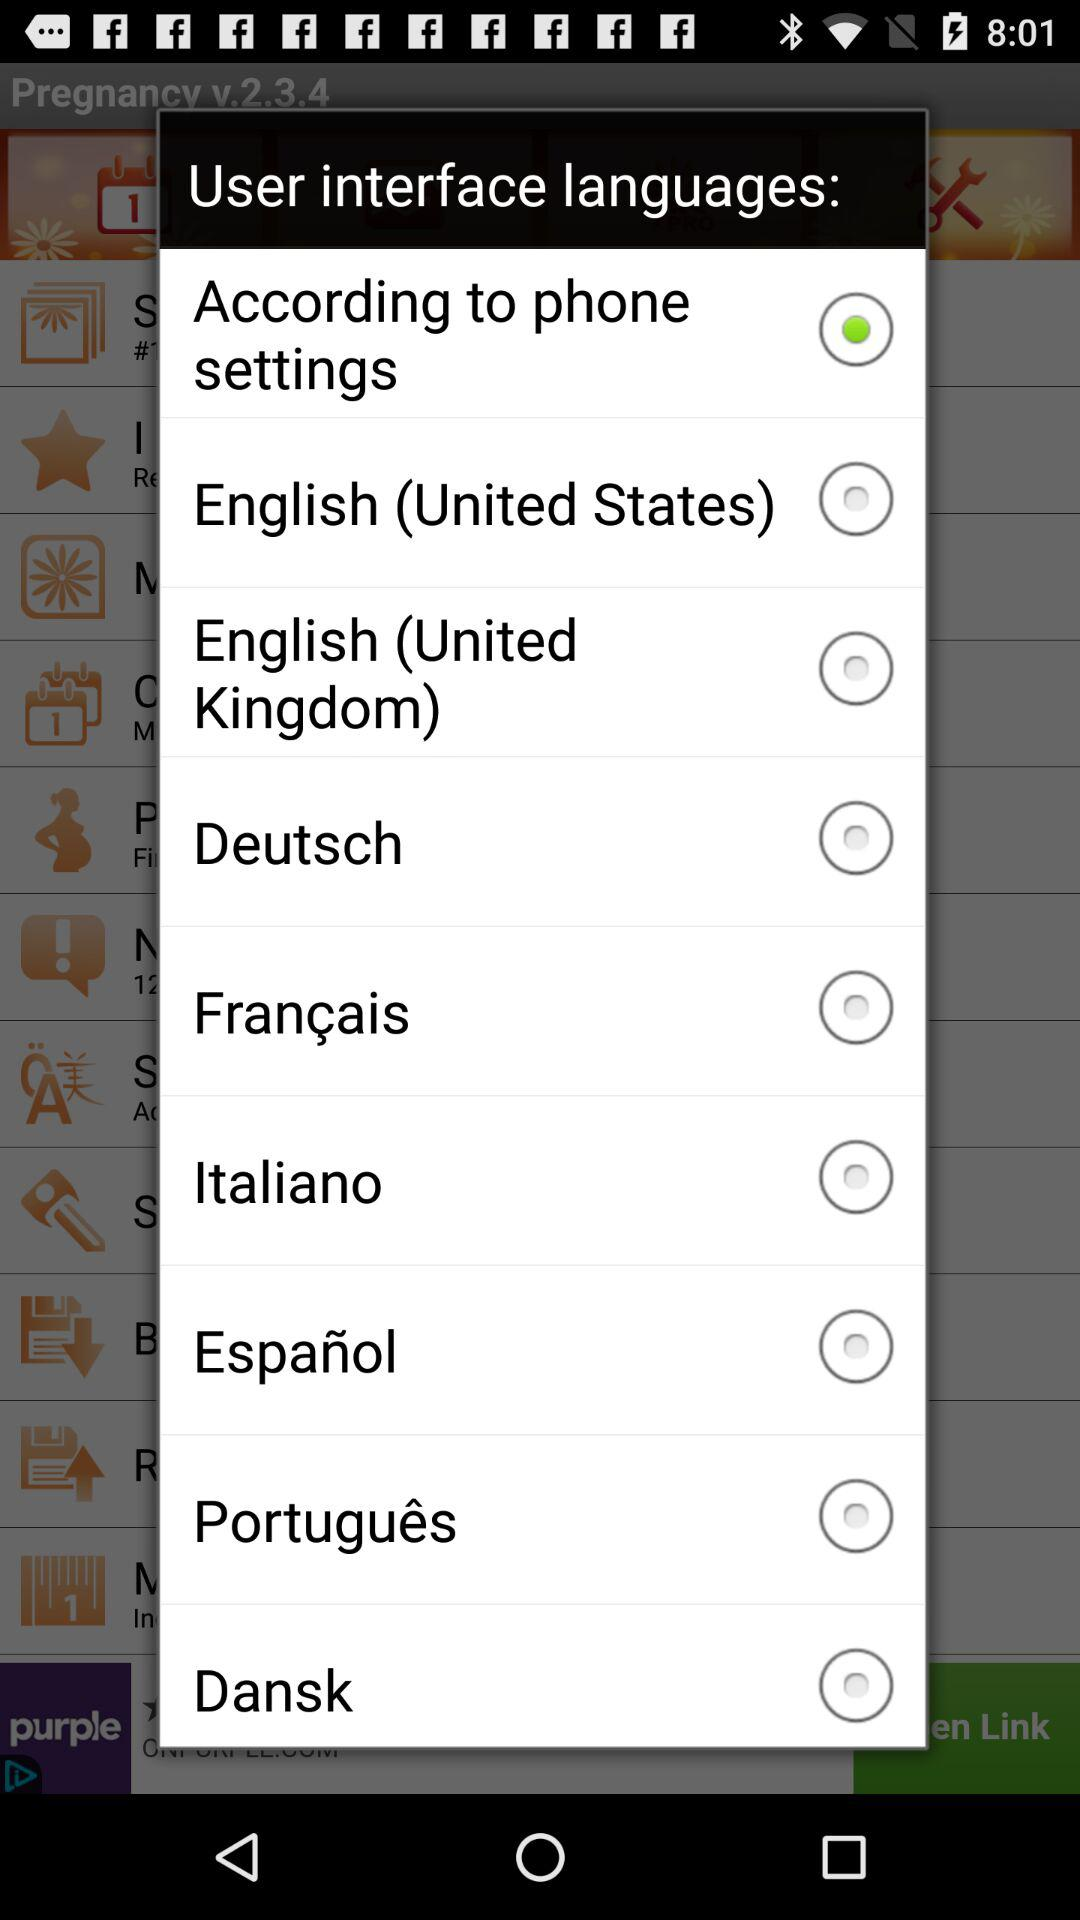What is the version? The version is v.2.3.4. 